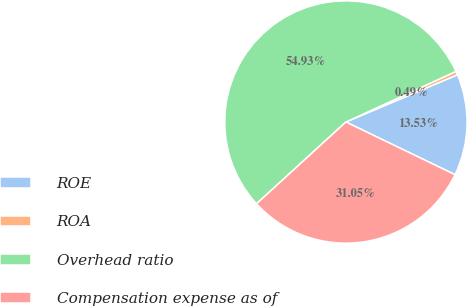<chart> <loc_0><loc_0><loc_500><loc_500><pie_chart><fcel>ROE<fcel>ROA<fcel>Overhead ratio<fcel>Compensation expense as of<nl><fcel>13.53%<fcel>0.49%<fcel>54.93%<fcel>31.05%<nl></chart> 